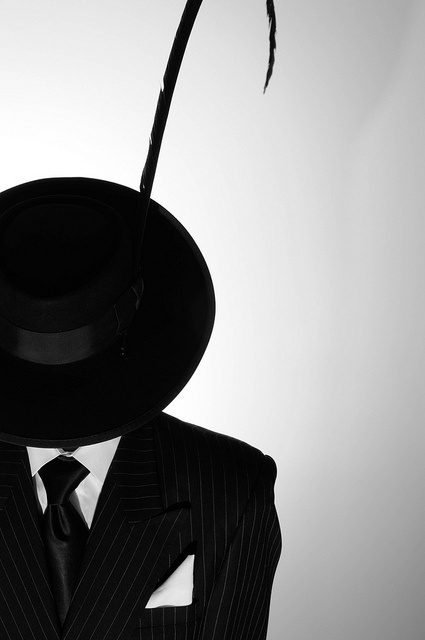Describe the objects in this image and their specific colors. I can see people in lightgray, black, darkgray, and gray tones and tie in lightgray, black, and gray tones in this image. 